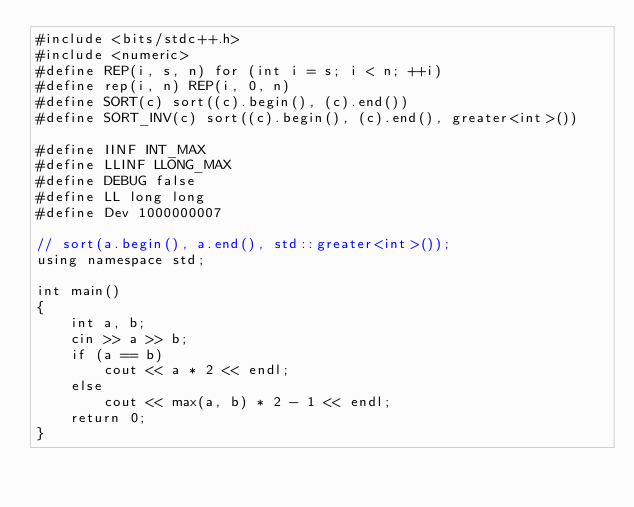<code> <loc_0><loc_0><loc_500><loc_500><_C++_>#include <bits/stdc++.h>
#include <numeric>
#define REP(i, s, n) for (int i = s; i < n; ++i)
#define rep(i, n) REP(i, 0, n)
#define SORT(c) sort((c).begin(), (c).end())
#define SORT_INV(c) sort((c).begin(), (c).end(), greater<int>())

#define IINF INT_MAX
#define LLINF LLONG_MAX
#define DEBUG false
#define LL long long
#define Dev 1000000007

// sort(a.begin(), a.end(), std::greater<int>());
using namespace std;

int main()
{
    int a, b;
    cin >> a >> b;
    if (a == b)
        cout << a * 2 << endl;
    else
        cout << max(a, b) * 2 - 1 << endl;
    return 0;
}</code> 